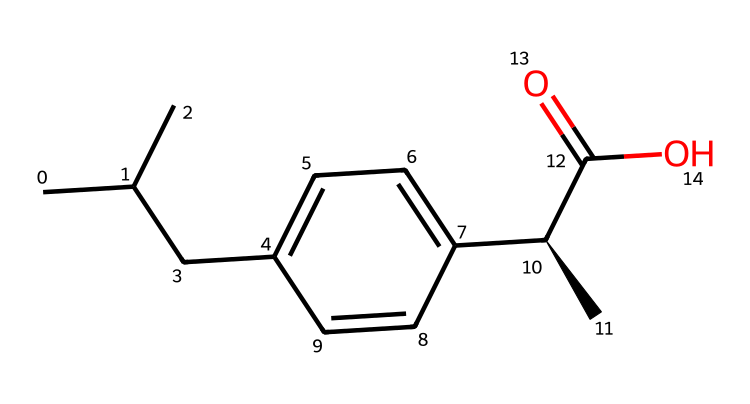What is the molecular formula of ibuprofen? The structure shows a total of 13 carbon (C) atoms, 18 hydrogen (H) atoms, and 2 oxygen (O) atoms. This gives the molecular formula as C13H18O2.
Answer: C13H18O2 How many chiral centers are present in ibuprofen? Looking at the structure, there is one carbon atom that is bonded to four different substituents (a chirality indicator). Thus, ibuprofen has one chiral center.
Answer: 1 What type of functional group is present in ibuprofen? The structure contains a carboxylic acid group (-COOH) indicated by the presence of a carbon atom bonded to a hydroxyl group (OH) and a carbonyl (C=O). This confirms the carboxylic acid functional group.
Answer: carboxylic acid What effect does chirality have on ibuprofen's biological activity? As a chiral compound, ibuprofen's activity can vary significantly between its enantiomers, meaning that one form may be more effective or have different side effects than the other. Thus, chirality influences its pharmacological properties.
Answer: pharmacological properties What is the significance of the chiral center in ibuprofen? The chiral center in ibuprofen determines its specific interaction with biological receptors, affecting its pain-relieving efficacy and side effects; the specific three-dimensional arrangement of atoms enables precise binding to target sites.
Answer: specific interaction How many rings are present in the structure of ibuprofen? Upon reviewing the structure of ibuprofen, we see that it does not contain any rings; it is a linear structure with side chains.
Answer: 0 